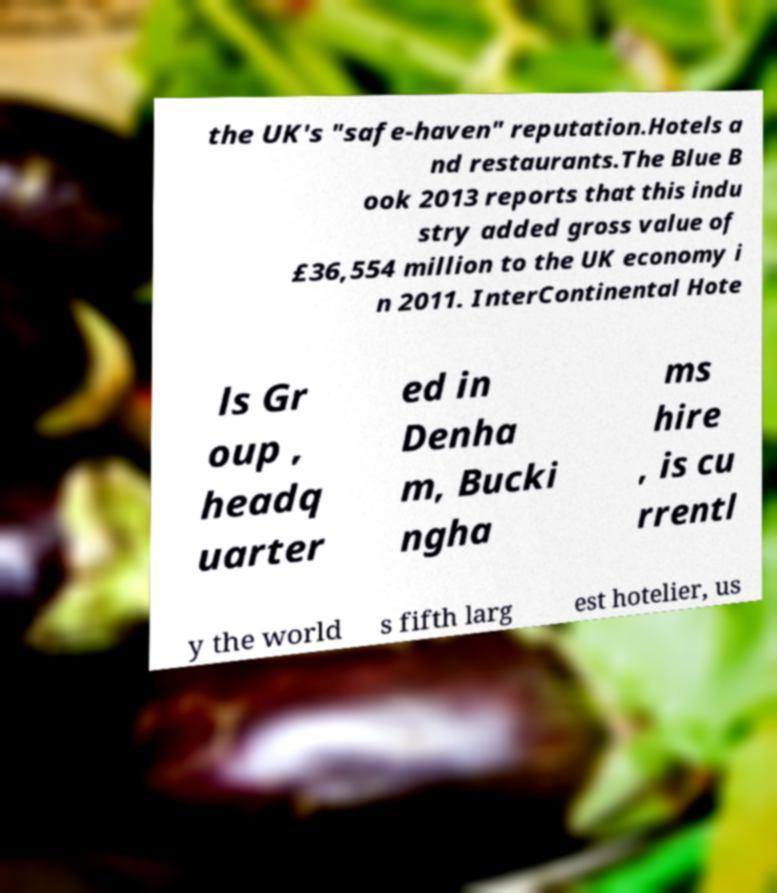There's text embedded in this image that I need extracted. Can you transcribe it verbatim? the UK's "safe-haven" reputation.Hotels a nd restaurants.The Blue B ook 2013 reports that this indu stry added gross value of £36,554 million to the UK economy i n 2011. InterContinental Hote ls Gr oup , headq uarter ed in Denha m, Bucki ngha ms hire , is cu rrentl y the world s fifth larg est hotelier, us 